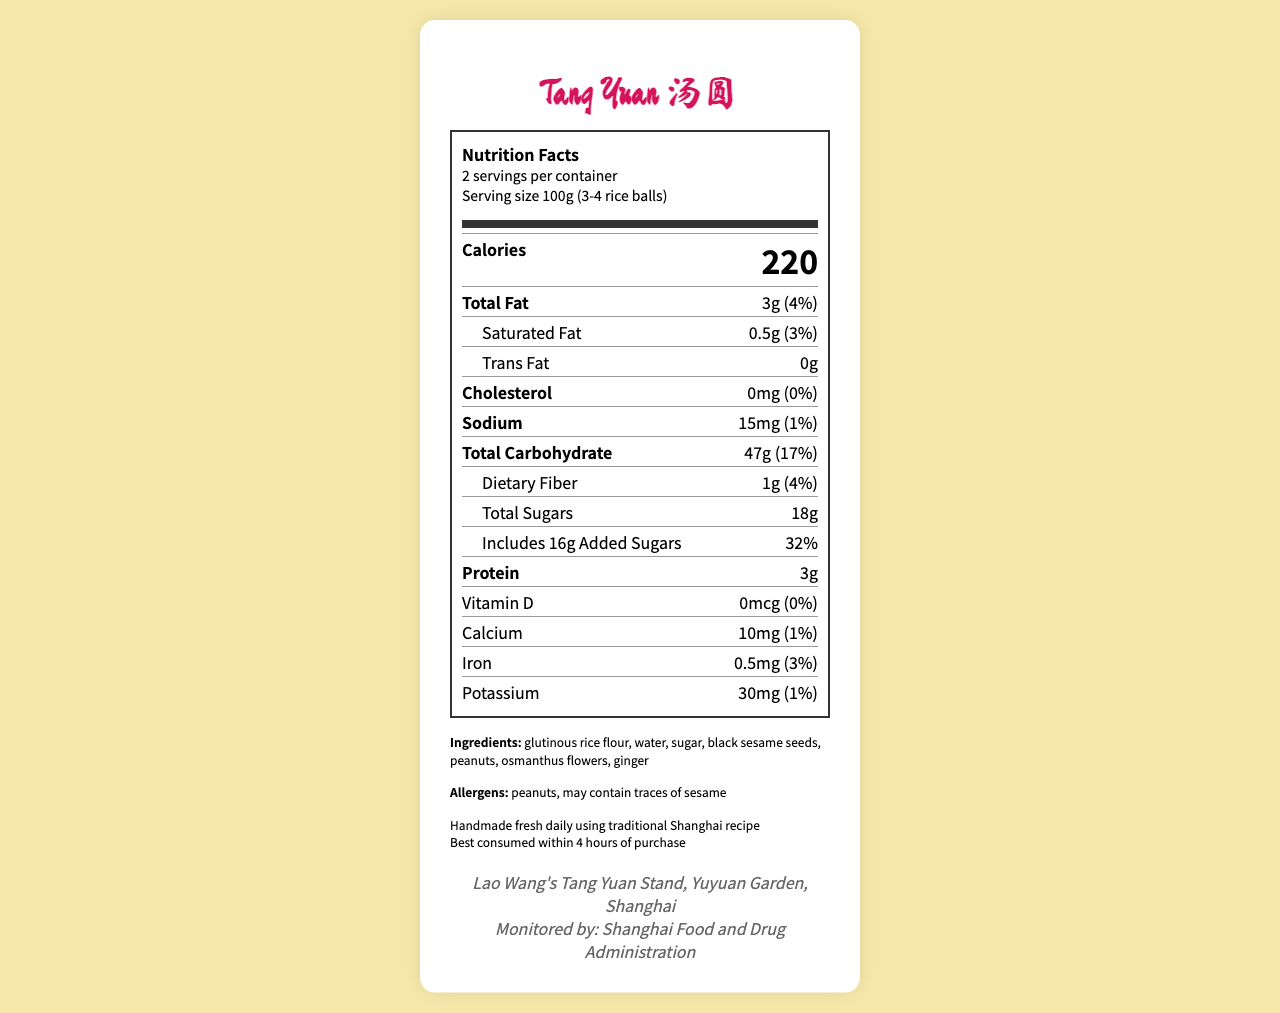what is the serving size? The serving size is specified as "100g (3-4 rice balls)" in the document.
Answer: 100g (3-4 rice balls) how many calories are there in one serving? The document lists "Calories" as "220" per serving.
Answer: 220 Calories what are the total sugars present in one serving? The document specifies "Total Sugars" as "18g".
Answer: 18g what is the main source of allergens in this product? The allergen section lists "peanuts" and "may contain traces of sesame".
Answer: Peanuts how much dietary fiber is in one serving? The document indicates "Dietary Fiber" as "1g".
Answer: 1g which ingredient is not in tang yuan? A. Glutinous rice flour B. Water C. Chocolate D. Sugar The listed ingredients include glutinous rice flour, water, and sugar, but not chocolate.
Answer: C what percentage of daily value for saturated fat does one serving of tang yuan provide? A. 1% B. 3% C. 5% D. 7% The document lists the saturated fat daily value as "3%".
Answer: B does this product contain any cholesterol? The document specifies cholesterol as "0mg" and daily value as "0%".
Answer: No which food authority monitors this product? The vendor info section mentions "Monitored by: Shanghai Food and Drug Administration".
Answer: Shanghai Food and Drug Administration summarize the main idea of the document. The document comprehensively outlines the nutritional content and related information for the sweet street treat, tang yuan, making it easy for consumers to understand its health impacts and origin.
Answer: The document provides detailed nutrition facts for tang yuan (glutinous rice balls in syrup), including serving size, calorie content, macro and micronutrients, ingredient list, allergen information, preparation and storage instructions, and vendor details monitored by the Shanghai Food and Drug Administration. what is the vitamin D content in one serving? The document lists "Vitamin D" as "0mcg".
Answer: 0mcg how many ingredients are used in the preparation of tang yuan? The ingredients section lists 7 items: glutinous rice flour, water, sugar, black sesame seeds, peanuts, osmanthus flowers, and ginger.
Answer: 7 where is Lao Wang's Tang Yuan Stand located? The vendor info section specifies the location as "Yuyuan Garden, Shanghai".
Answer: Yuyuan Garden, Shanghai how much protein does one serving of tang yuan provide? The document states the protein content as "3g".
Answer: 3g can you determine if this product is gluten-free? The document does not provide information about whether the product is gluten-free or not.
Answer: Not enough information 